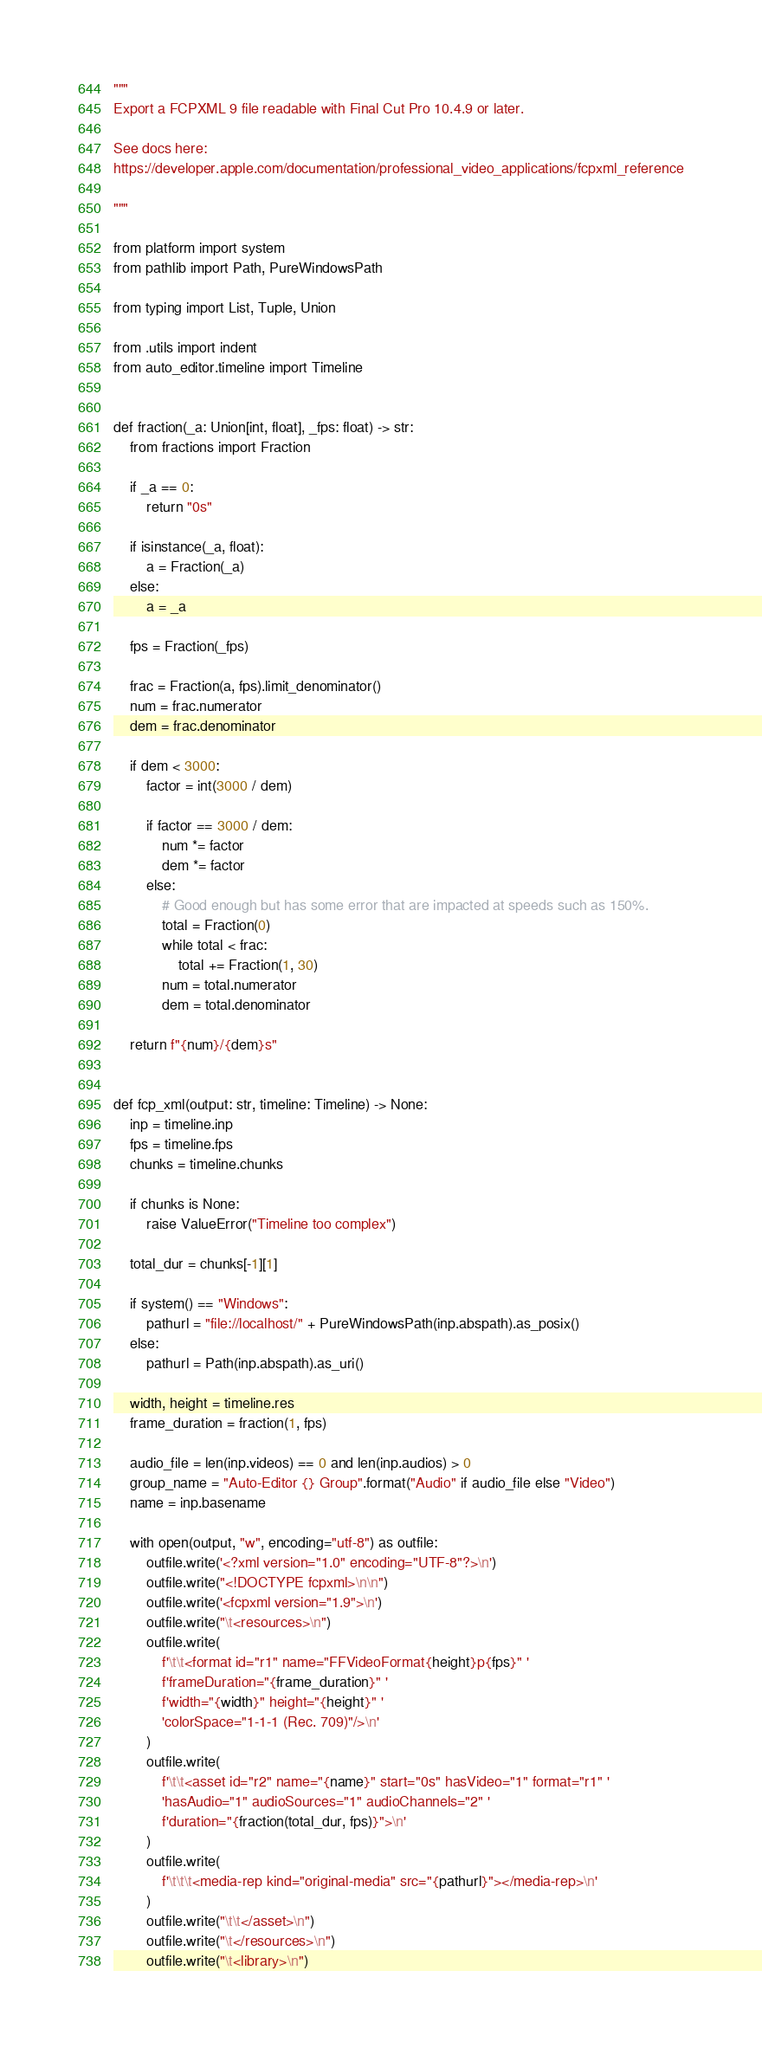Convert code to text. <code><loc_0><loc_0><loc_500><loc_500><_Python_>"""
Export a FCPXML 9 file readable with Final Cut Pro 10.4.9 or later.

See docs here:
https://developer.apple.com/documentation/professional_video_applications/fcpxml_reference

"""

from platform import system
from pathlib import Path, PureWindowsPath

from typing import List, Tuple, Union

from .utils import indent
from auto_editor.timeline import Timeline


def fraction(_a: Union[int, float], _fps: float) -> str:
    from fractions import Fraction

    if _a == 0:
        return "0s"

    if isinstance(_a, float):
        a = Fraction(_a)
    else:
        a = _a

    fps = Fraction(_fps)

    frac = Fraction(a, fps).limit_denominator()
    num = frac.numerator
    dem = frac.denominator

    if dem < 3000:
        factor = int(3000 / dem)

        if factor == 3000 / dem:
            num *= factor
            dem *= factor
        else:
            # Good enough but has some error that are impacted at speeds such as 150%.
            total = Fraction(0)
            while total < frac:
                total += Fraction(1, 30)
            num = total.numerator
            dem = total.denominator

    return f"{num}/{dem}s"


def fcp_xml(output: str, timeline: Timeline) -> None:
    inp = timeline.inp
    fps = timeline.fps
    chunks = timeline.chunks

    if chunks is None:
        raise ValueError("Timeline too complex")

    total_dur = chunks[-1][1]

    if system() == "Windows":
        pathurl = "file://localhost/" + PureWindowsPath(inp.abspath).as_posix()
    else:
        pathurl = Path(inp.abspath).as_uri()

    width, height = timeline.res
    frame_duration = fraction(1, fps)

    audio_file = len(inp.videos) == 0 and len(inp.audios) > 0
    group_name = "Auto-Editor {} Group".format("Audio" if audio_file else "Video")
    name = inp.basename

    with open(output, "w", encoding="utf-8") as outfile:
        outfile.write('<?xml version="1.0" encoding="UTF-8"?>\n')
        outfile.write("<!DOCTYPE fcpxml>\n\n")
        outfile.write('<fcpxml version="1.9">\n')
        outfile.write("\t<resources>\n")
        outfile.write(
            f'\t\t<format id="r1" name="FFVideoFormat{height}p{fps}" '
            f'frameDuration="{frame_duration}" '
            f'width="{width}" height="{height}" '
            'colorSpace="1-1-1 (Rec. 709)"/>\n'
        )
        outfile.write(
            f'\t\t<asset id="r2" name="{name}" start="0s" hasVideo="1" format="r1" '
            'hasAudio="1" audioSources="1" audioChannels="2" '
            f'duration="{fraction(total_dur, fps)}">\n'
        )
        outfile.write(
            f'\t\t\t<media-rep kind="original-media" src="{pathurl}"></media-rep>\n'
        )
        outfile.write("\t\t</asset>\n")
        outfile.write("\t</resources>\n")
        outfile.write("\t<library>\n")</code> 